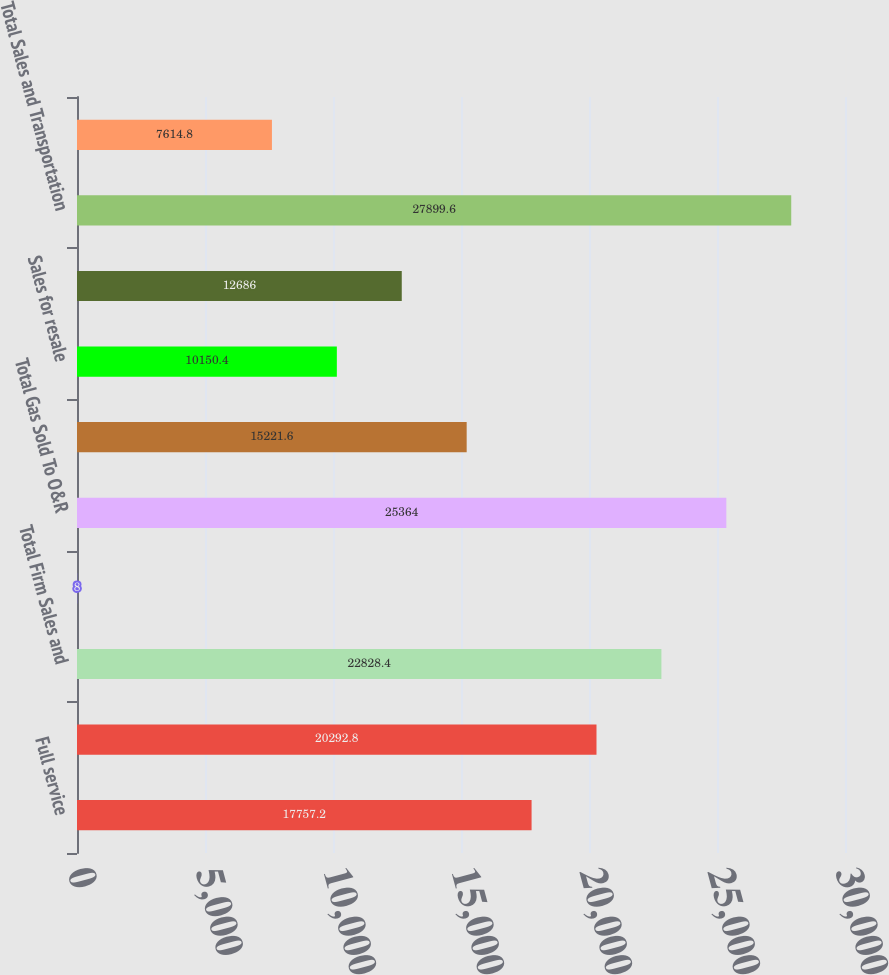<chart> <loc_0><loc_0><loc_500><loc_500><bar_chart><fcel>Full service<fcel>Firm transportation<fcel>Total Firm Sales and<fcel>Interruptible Sales<fcel>Total Gas Sold To O&R<fcel>Interruptible transportation<fcel>Sales for resale<fcel>Sales to electric generating<fcel>Total Sales and Transportation<fcel>Other operating revenues<nl><fcel>17757.2<fcel>20292.8<fcel>22828.4<fcel>8<fcel>25364<fcel>15221.6<fcel>10150.4<fcel>12686<fcel>27899.6<fcel>7614.8<nl></chart> 